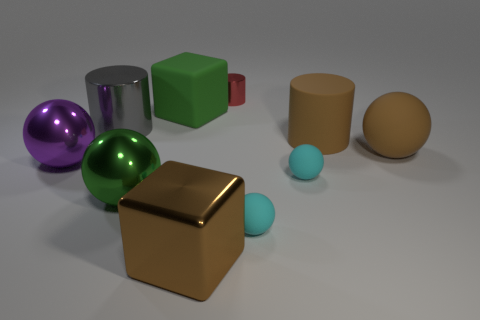There is a thing that is left of the large cylinder that is on the left side of the brown cylinder; how big is it?
Make the answer very short. Large. There is a thing that is both behind the gray cylinder and in front of the tiny metal cylinder; what material is it?
Give a very brief answer. Rubber. What is the color of the big rubber sphere?
Offer a very short reply. Brown. What is the shape of the large rubber thing that is to the left of the large brown metal cube?
Your response must be concise. Cube. There is a brown matte ball right of the big cylinder that is to the right of the brown block; are there any large rubber balls that are behind it?
Your response must be concise. No. Are there any other things that have the same shape as the large brown shiny object?
Offer a very short reply. Yes. Are any small cyan rubber balls visible?
Offer a very short reply. Yes. Do the large brown thing that is in front of the brown ball and the big cylinder to the right of the matte cube have the same material?
Offer a very short reply. No. What is the size of the brown thing to the right of the cylinder that is right of the metallic thing behind the green rubber object?
Provide a succinct answer. Large. What number of big brown cylinders have the same material as the brown sphere?
Make the answer very short. 1. 